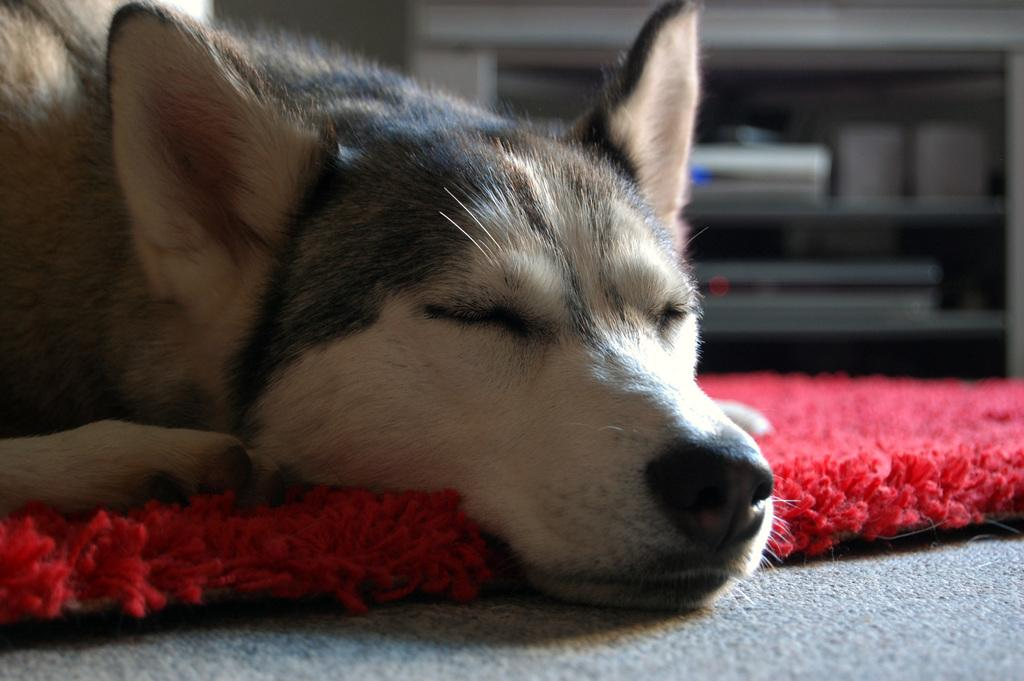What type of animal can be seen in the image? There is a dog in the image. What is the dog doing in the image? The dog is sleeping. What color is the floor mat that the dog is lying on? The floor mat is red in color. What can be seen in the background of the image? There are electronic devices in the background. How are the electronic devices arranged in the image? The electronic devices are in a rack. What route does the dog take to meet its friends in the image? There is no indication of the dog meeting friends or taking a route in the image; the dog is simply sleeping on a red floor mat. 